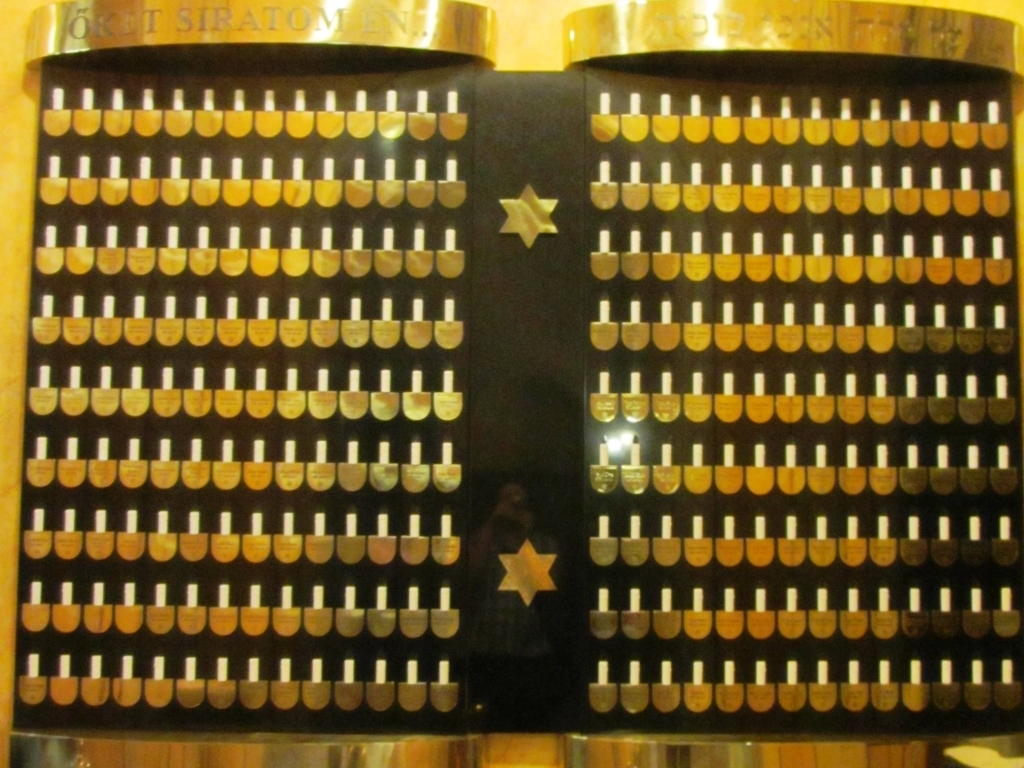Could you explain how this device might have been operated? Each column of keys likely corresponds to a digit in a number, and pressing down on a key would enter that digit into the machine. Calculations were performed by a series of gears and levers inside the device, and results would be displayed on dials or another form of readout not visible in this image. 